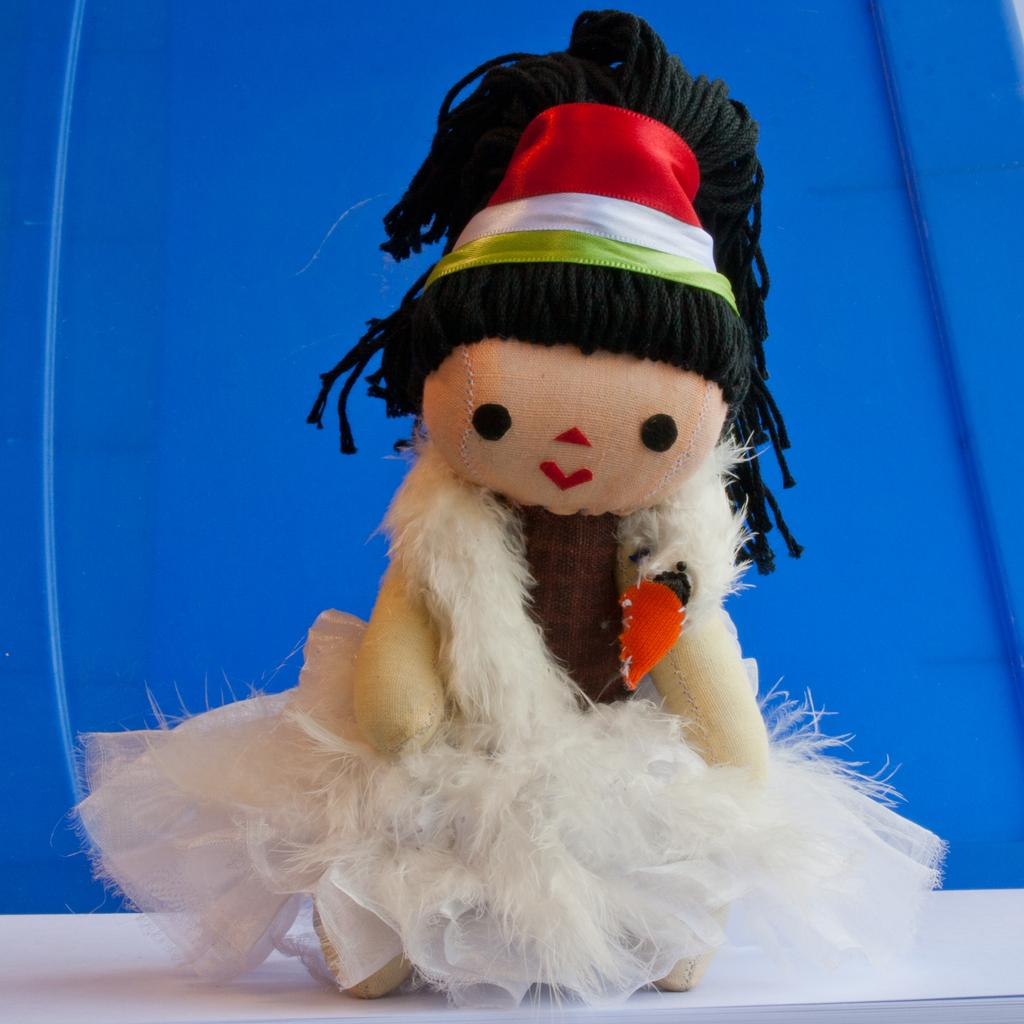What is the main subject of the image? There is a doll in the image. Where is the doll located? The doll is on a white table. Can you describe anything in the background of the image? There is a blue color object in the background of the image. Can you tell me how many horses are present in the image? There are no horses present in the image; it features a doll on a white table. Does the existence of the doll in the image prove the existence of a home? The presence of the doll in the image does not necessarily prove the existence of a home, as it could be in any setting. 